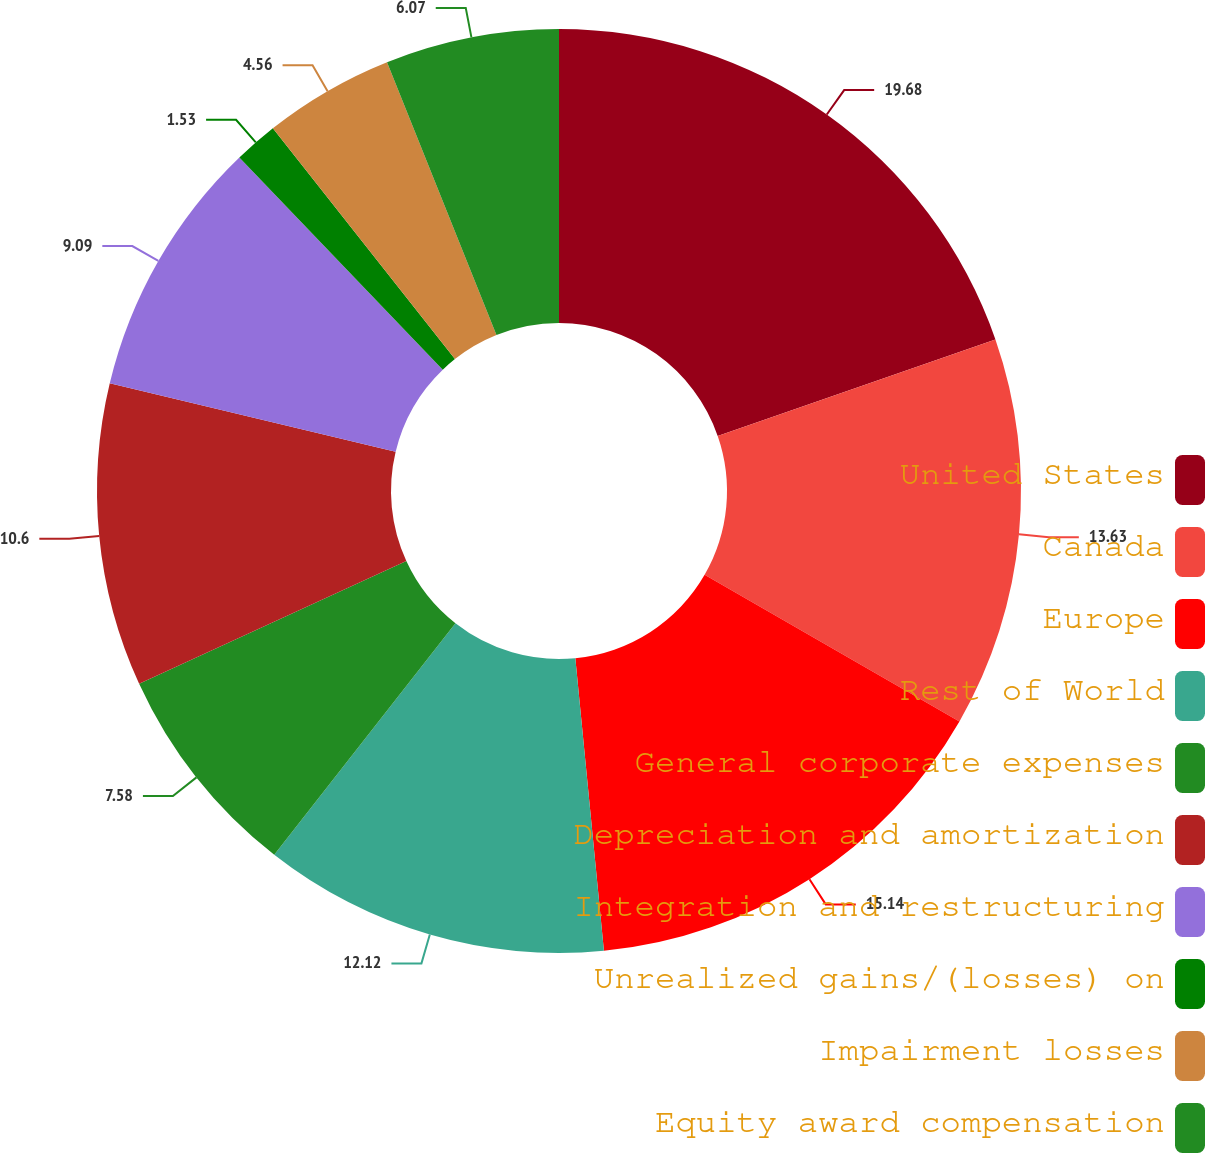Convert chart to OTSL. <chart><loc_0><loc_0><loc_500><loc_500><pie_chart><fcel>United States<fcel>Canada<fcel>Europe<fcel>Rest of World<fcel>General corporate expenses<fcel>Depreciation and amortization<fcel>Integration and restructuring<fcel>Unrealized gains/(losses) on<fcel>Impairment losses<fcel>Equity award compensation<nl><fcel>19.68%<fcel>13.63%<fcel>15.14%<fcel>12.12%<fcel>7.58%<fcel>10.6%<fcel>9.09%<fcel>1.53%<fcel>4.56%<fcel>6.07%<nl></chart> 